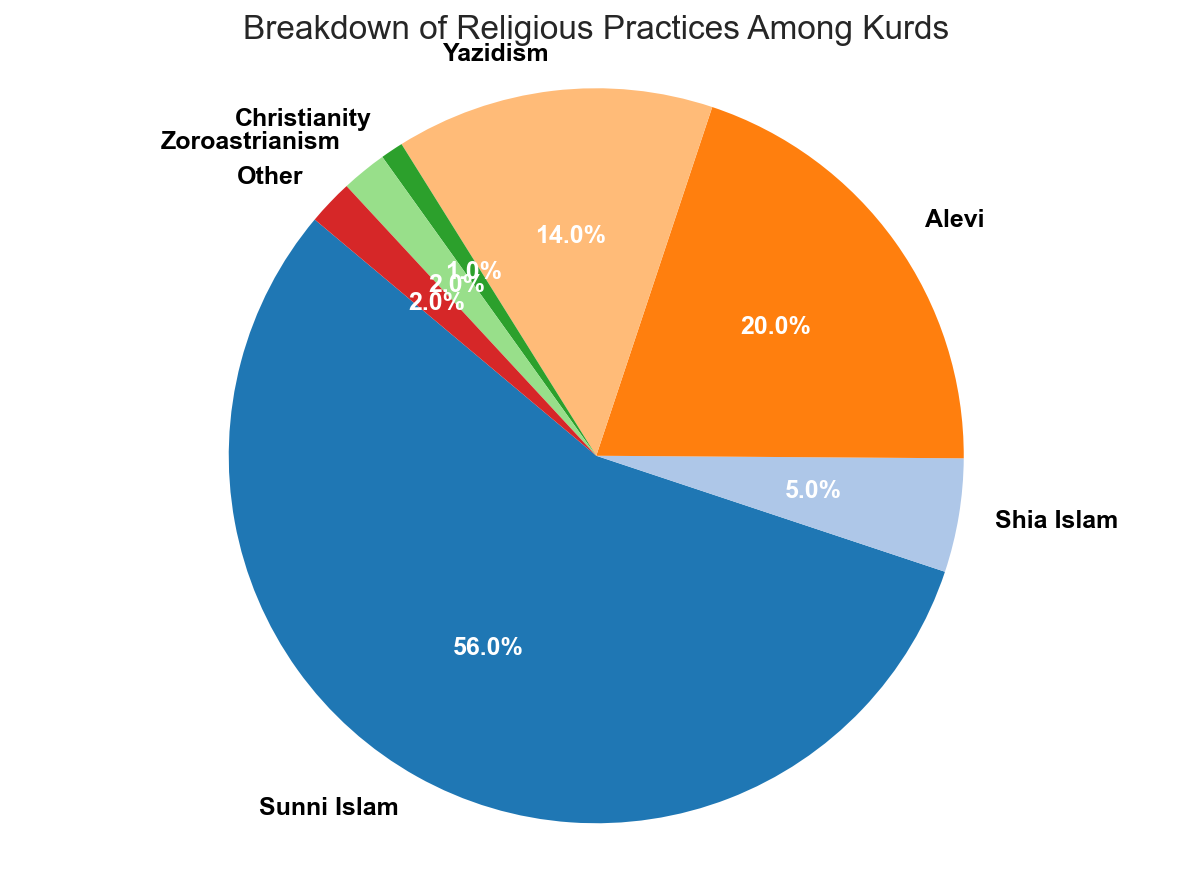What percentage of Kurds practice Sunni Islam? The figure clearly shows the breakdown of religious practices among Kurds, and the largest section represents Sunni Islam. By looking at the label next to this section, it is marked as 56%.
Answer: 56% How much more prevalent is Sunni Islam compared to Alevi among Kurds? To find how much more prevalent Sunni Islam is compared to Alevi, subtract the percentage of Alevi (20%) from the percentage of Sunni Islam (56%). This yields 56% - 20% = 36%.
Answer: 36% What is the combined percentage of Kurds practicing Yazidism and Zoroastrianism? To find the combined percentage, add the percentage of Yazidism (14%) with Zoroastrianism (2%). This gives 14% + 2% = 16%.
Answer: 16% Which religious practices have the smallest percentages among Kurds? By examining the pie chart, the smallest sections are for Christianity (1%) and Zoroastrianism (2%), as well as the "Other" category (2%).
Answer: Christianity and Zoroastrianism, and Other Is Sunni Islam more than half of the religious practices among Kurds? Looking at the chart, Sunni Islam represents 56% of the practices. Since 56% is more than half (50%), Sunni Islam indeed constitutes more than half.
Answer: Yes What color is used to represent Yazidism in the chart? By looking at the pie chart, identify the section for Yazidism, which represents 14%. Check the associated color visually on the chart.
Answer: (Specify Yazidism color) How big is the difference between the percentages of those practicing Christianity and those practicing Zoroastrianism? Subtract the percentage of Christianity (1%) from Zoroastrianism (2%). This yields a difference of 2% - 1% = 1%.
Answer: 1% What is the collective percentage of Alevi, Yazidism, and "Other" religious practices? Add the percentages of Alevi (20%), Yazidism (14%), and Other (2%). The total is 20% + 14% + 2% = 36%.
Answer: 36% Is the number of Kurds practicing Shia Islam greater than those practicing Zoroastrianism? By checking the chart, Shia Islam constitutes 5%, whereas Zoroastrianism is 2%. Since 5% is greater than 2%, the answer is yes.
Answer: Yes What is the third largest religious practice among Kurds? By arranging the percentages in descending order, the practices are: Sunni Islam (56%), Alevi (20%), and Yazidism (14%). Thus, Yazidism is the third largest.
Answer: Yazidism 